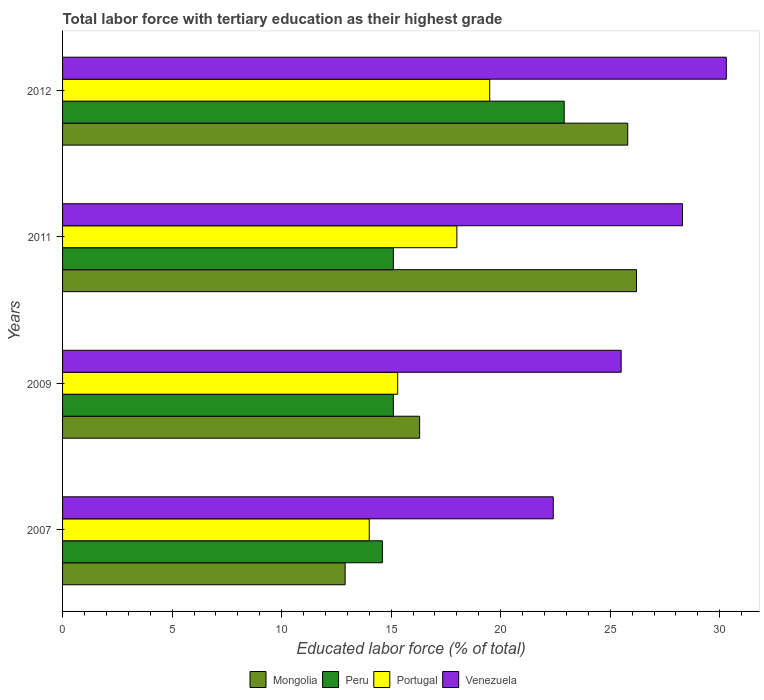How many different coloured bars are there?
Your answer should be compact. 4. Are the number of bars on each tick of the Y-axis equal?
Your answer should be compact. Yes. How many bars are there on the 4th tick from the top?
Offer a very short reply. 4. In how many cases, is the number of bars for a given year not equal to the number of legend labels?
Offer a terse response. 0. Across all years, what is the maximum percentage of male labor force with tertiary education in Mongolia?
Provide a short and direct response. 26.2. Across all years, what is the minimum percentage of male labor force with tertiary education in Mongolia?
Offer a terse response. 12.9. In which year was the percentage of male labor force with tertiary education in Venezuela maximum?
Provide a short and direct response. 2012. What is the total percentage of male labor force with tertiary education in Peru in the graph?
Your answer should be very brief. 67.7. What is the difference between the percentage of male labor force with tertiary education in Mongolia in 2011 and that in 2012?
Keep it short and to the point. 0.4. What is the difference between the percentage of male labor force with tertiary education in Mongolia in 2009 and the percentage of male labor force with tertiary education in Portugal in 2011?
Keep it short and to the point. -1.7. What is the average percentage of male labor force with tertiary education in Mongolia per year?
Your answer should be compact. 20.3. In the year 2012, what is the difference between the percentage of male labor force with tertiary education in Mongolia and percentage of male labor force with tertiary education in Peru?
Your response must be concise. 2.9. What is the ratio of the percentage of male labor force with tertiary education in Peru in 2011 to that in 2012?
Offer a terse response. 0.66. Is the percentage of male labor force with tertiary education in Peru in 2007 less than that in 2009?
Your answer should be very brief. Yes. Is the difference between the percentage of male labor force with tertiary education in Mongolia in 2007 and 2009 greater than the difference between the percentage of male labor force with tertiary education in Peru in 2007 and 2009?
Provide a succinct answer. No. What is the difference between the highest and the lowest percentage of male labor force with tertiary education in Venezuela?
Provide a succinct answer. 7.9. Is the sum of the percentage of male labor force with tertiary education in Peru in 2009 and 2012 greater than the maximum percentage of male labor force with tertiary education in Portugal across all years?
Give a very brief answer. Yes. Is it the case that in every year, the sum of the percentage of male labor force with tertiary education in Portugal and percentage of male labor force with tertiary education in Venezuela is greater than the sum of percentage of male labor force with tertiary education in Mongolia and percentage of male labor force with tertiary education in Peru?
Provide a short and direct response. Yes. What does the 4th bar from the top in 2012 represents?
Provide a succinct answer. Mongolia. Are all the bars in the graph horizontal?
Your answer should be very brief. Yes. What is the difference between two consecutive major ticks on the X-axis?
Keep it short and to the point. 5. Are the values on the major ticks of X-axis written in scientific E-notation?
Offer a terse response. No. Does the graph contain grids?
Your answer should be compact. No. How many legend labels are there?
Your response must be concise. 4. How are the legend labels stacked?
Offer a very short reply. Horizontal. What is the title of the graph?
Make the answer very short. Total labor force with tertiary education as their highest grade. Does "Azerbaijan" appear as one of the legend labels in the graph?
Provide a succinct answer. No. What is the label or title of the X-axis?
Offer a terse response. Educated labor force (% of total). What is the label or title of the Y-axis?
Your answer should be compact. Years. What is the Educated labor force (% of total) in Mongolia in 2007?
Offer a very short reply. 12.9. What is the Educated labor force (% of total) of Peru in 2007?
Your response must be concise. 14.6. What is the Educated labor force (% of total) in Portugal in 2007?
Your response must be concise. 14. What is the Educated labor force (% of total) of Venezuela in 2007?
Make the answer very short. 22.4. What is the Educated labor force (% of total) in Mongolia in 2009?
Keep it short and to the point. 16.3. What is the Educated labor force (% of total) of Peru in 2009?
Your answer should be very brief. 15.1. What is the Educated labor force (% of total) of Portugal in 2009?
Offer a very short reply. 15.3. What is the Educated labor force (% of total) of Mongolia in 2011?
Make the answer very short. 26.2. What is the Educated labor force (% of total) in Peru in 2011?
Your response must be concise. 15.1. What is the Educated labor force (% of total) in Venezuela in 2011?
Your response must be concise. 28.3. What is the Educated labor force (% of total) in Mongolia in 2012?
Make the answer very short. 25.8. What is the Educated labor force (% of total) in Peru in 2012?
Provide a succinct answer. 22.9. What is the Educated labor force (% of total) of Portugal in 2012?
Keep it short and to the point. 19.5. What is the Educated labor force (% of total) of Venezuela in 2012?
Make the answer very short. 30.3. Across all years, what is the maximum Educated labor force (% of total) of Mongolia?
Your answer should be very brief. 26.2. Across all years, what is the maximum Educated labor force (% of total) in Peru?
Provide a short and direct response. 22.9. Across all years, what is the maximum Educated labor force (% of total) of Venezuela?
Keep it short and to the point. 30.3. Across all years, what is the minimum Educated labor force (% of total) of Mongolia?
Provide a short and direct response. 12.9. Across all years, what is the minimum Educated labor force (% of total) in Peru?
Your answer should be very brief. 14.6. Across all years, what is the minimum Educated labor force (% of total) in Portugal?
Your response must be concise. 14. Across all years, what is the minimum Educated labor force (% of total) in Venezuela?
Offer a terse response. 22.4. What is the total Educated labor force (% of total) in Mongolia in the graph?
Offer a very short reply. 81.2. What is the total Educated labor force (% of total) of Peru in the graph?
Offer a terse response. 67.7. What is the total Educated labor force (% of total) in Portugal in the graph?
Give a very brief answer. 66.8. What is the total Educated labor force (% of total) of Venezuela in the graph?
Your response must be concise. 106.5. What is the difference between the Educated labor force (% of total) of Mongolia in 2007 and that in 2009?
Your response must be concise. -3.4. What is the difference between the Educated labor force (% of total) of Venezuela in 2007 and that in 2009?
Ensure brevity in your answer.  -3.1. What is the difference between the Educated labor force (% of total) in Peru in 2007 and that in 2011?
Offer a terse response. -0.5. What is the difference between the Educated labor force (% of total) in Mongolia in 2007 and that in 2012?
Ensure brevity in your answer.  -12.9. What is the difference between the Educated labor force (% of total) in Peru in 2007 and that in 2012?
Give a very brief answer. -8.3. What is the difference between the Educated labor force (% of total) in Venezuela in 2007 and that in 2012?
Provide a short and direct response. -7.9. What is the difference between the Educated labor force (% of total) of Peru in 2009 and that in 2012?
Offer a very short reply. -7.8. What is the difference between the Educated labor force (% of total) of Venezuela in 2009 and that in 2012?
Your answer should be compact. -4.8. What is the difference between the Educated labor force (% of total) in Portugal in 2011 and that in 2012?
Offer a terse response. -1.5. What is the difference between the Educated labor force (% of total) in Mongolia in 2007 and the Educated labor force (% of total) in Peru in 2009?
Give a very brief answer. -2.2. What is the difference between the Educated labor force (% of total) in Mongolia in 2007 and the Educated labor force (% of total) in Venezuela in 2009?
Keep it short and to the point. -12.6. What is the difference between the Educated labor force (% of total) in Peru in 2007 and the Educated labor force (% of total) in Portugal in 2009?
Make the answer very short. -0.7. What is the difference between the Educated labor force (% of total) of Peru in 2007 and the Educated labor force (% of total) of Venezuela in 2009?
Provide a succinct answer. -10.9. What is the difference between the Educated labor force (% of total) of Mongolia in 2007 and the Educated labor force (% of total) of Peru in 2011?
Make the answer very short. -2.2. What is the difference between the Educated labor force (% of total) in Mongolia in 2007 and the Educated labor force (% of total) in Portugal in 2011?
Provide a short and direct response. -5.1. What is the difference between the Educated labor force (% of total) of Mongolia in 2007 and the Educated labor force (% of total) of Venezuela in 2011?
Your answer should be compact. -15.4. What is the difference between the Educated labor force (% of total) of Peru in 2007 and the Educated labor force (% of total) of Portugal in 2011?
Your response must be concise. -3.4. What is the difference between the Educated labor force (% of total) in Peru in 2007 and the Educated labor force (% of total) in Venezuela in 2011?
Make the answer very short. -13.7. What is the difference between the Educated labor force (% of total) of Portugal in 2007 and the Educated labor force (% of total) of Venezuela in 2011?
Offer a very short reply. -14.3. What is the difference between the Educated labor force (% of total) of Mongolia in 2007 and the Educated labor force (% of total) of Venezuela in 2012?
Your answer should be very brief. -17.4. What is the difference between the Educated labor force (% of total) of Peru in 2007 and the Educated labor force (% of total) of Venezuela in 2012?
Offer a very short reply. -15.7. What is the difference between the Educated labor force (% of total) in Portugal in 2007 and the Educated labor force (% of total) in Venezuela in 2012?
Keep it short and to the point. -16.3. What is the difference between the Educated labor force (% of total) in Mongolia in 2009 and the Educated labor force (% of total) in Peru in 2011?
Your answer should be compact. 1.2. What is the difference between the Educated labor force (% of total) in Mongolia in 2009 and the Educated labor force (% of total) in Venezuela in 2011?
Give a very brief answer. -12. What is the difference between the Educated labor force (% of total) in Portugal in 2009 and the Educated labor force (% of total) in Venezuela in 2011?
Your response must be concise. -13. What is the difference between the Educated labor force (% of total) in Mongolia in 2009 and the Educated labor force (% of total) in Portugal in 2012?
Offer a very short reply. -3.2. What is the difference between the Educated labor force (% of total) in Mongolia in 2009 and the Educated labor force (% of total) in Venezuela in 2012?
Offer a terse response. -14. What is the difference between the Educated labor force (% of total) of Peru in 2009 and the Educated labor force (% of total) of Portugal in 2012?
Your answer should be compact. -4.4. What is the difference between the Educated labor force (% of total) of Peru in 2009 and the Educated labor force (% of total) of Venezuela in 2012?
Give a very brief answer. -15.2. What is the difference between the Educated labor force (% of total) of Portugal in 2009 and the Educated labor force (% of total) of Venezuela in 2012?
Your answer should be compact. -15. What is the difference between the Educated labor force (% of total) in Mongolia in 2011 and the Educated labor force (% of total) in Peru in 2012?
Offer a terse response. 3.3. What is the difference between the Educated labor force (% of total) in Mongolia in 2011 and the Educated labor force (% of total) in Venezuela in 2012?
Offer a very short reply. -4.1. What is the difference between the Educated labor force (% of total) in Peru in 2011 and the Educated labor force (% of total) in Portugal in 2012?
Your response must be concise. -4.4. What is the difference between the Educated labor force (% of total) in Peru in 2011 and the Educated labor force (% of total) in Venezuela in 2012?
Ensure brevity in your answer.  -15.2. What is the average Educated labor force (% of total) in Mongolia per year?
Offer a terse response. 20.3. What is the average Educated labor force (% of total) in Peru per year?
Make the answer very short. 16.93. What is the average Educated labor force (% of total) of Venezuela per year?
Offer a terse response. 26.62. In the year 2007, what is the difference between the Educated labor force (% of total) of Mongolia and Educated labor force (% of total) of Peru?
Your response must be concise. -1.7. In the year 2007, what is the difference between the Educated labor force (% of total) in Peru and Educated labor force (% of total) in Venezuela?
Your response must be concise. -7.8. In the year 2009, what is the difference between the Educated labor force (% of total) in Mongolia and Educated labor force (% of total) in Portugal?
Provide a succinct answer. 1. In the year 2009, what is the difference between the Educated labor force (% of total) in Peru and Educated labor force (% of total) in Portugal?
Offer a terse response. -0.2. In the year 2009, what is the difference between the Educated labor force (% of total) of Peru and Educated labor force (% of total) of Venezuela?
Provide a succinct answer. -10.4. In the year 2011, what is the difference between the Educated labor force (% of total) of Mongolia and Educated labor force (% of total) of Peru?
Keep it short and to the point. 11.1. In the year 2011, what is the difference between the Educated labor force (% of total) of Peru and Educated labor force (% of total) of Venezuela?
Offer a very short reply. -13.2. In the year 2012, what is the difference between the Educated labor force (% of total) in Mongolia and Educated labor force (% of total) in Portugal?
Your response must be concise. 6.3. In the year 2012, what is the difference between the Educated labor force (% of total) of Peru and Educated labor force (% of total) of Portugal?
Make the answer very short. 3.4. In the year 2012, what is the difference between the Educated labor force (% of total) of Peru and Educated labor force (% of total) of Venezuela?
Give a very brief answer. -7.4. In the year 2012, what is the difference between the Educated labor force (% of total) of Portugal and Educated labor force (% of total) of Venezuela?
Provide a succinct answer. -10.8. What is the ratio of the Educated labor force (% of total) of Mongolia in 2007 to that in 2009?
Make the answer very short. 0.79. What is the ratio of the Educated labor force (% of total) in Peru in 2007 to that in 2009?
Ensure brevity in your answer.  0.97. What is the ratio of the Educated labor force (% of total) of Portugal in 2007 to that in 2009?
Make the answer very short. 0.92. What is the ratio of the Educated labor force (% of total) of Venezuela in 2007 to that in 2009?
Your response must be concise. 0.88. What is the ratio of the Educated labor force (% of total) in Mongolia in 2007 to that in 2011?
Ensure brevity in your answer.  0.49. What is the ratio of the Educated labor force (% of total) of Peru in 2007 to that in 2011?
Your answer should be very brief. 0.97. What is the ratio of the Educated labor force (% of total) of Venezuela in 2007 to that in 2011?
Provide a succinct answer. 0.79. What is the ratio of the Educated labor force (% of total) of Peru in 2007 to that in 2012?
Offer a very short reply. 0.64. What is the ratio of the Educated labor force (% of total) of Portugal in 2007 to that in 2012?
Your response must be concise. 0.72. What is the ratio of the Educated labor force (% of total) in Venezuela in 2007 to that in 2012?
Keep it short and to the point. 0.74. What is the ratio of the Educated labor force (% of total) in Mongolia in 2009 to that in 2011?
Your answer should be compact. 0.62. What is the ratio of the Educated labor force (% of total) of Peru in 2009 to that in 2011?
Give a very brief answer. 1. What is the ratio of the Educated labor force (% of total) in Venezuela in 2009 to that in 2011?
Offer a terse response. 0.9. What is the ratio of the Educated labor force (% of total) in Mongolia in 2009 to that in 2012?
Offer a very short reply. 0.63. What is the ratio of the Educated labor force (% of total) in Peru in 2009 to that in 2012?
Your answer should be very brief. 0.66. What is the ratio of the Educated labor force (% of total) in Portugal in 2009 to that in 2012?
Make the answer very short. 0.78. What is the ratio of the Educated labor force (% of total) in Venezuela in 2009 to that in 2012?
Provide a succinct answer. 0.84. What is the ratio of the Educated labor force (% of total) in Mongolia in 2011 to that in 2012?
Provide a succinct answer. 1.02. What is the ratio of the Educated labor force (% of total) in Peru in 2011 to that in 2012?
Provide a short and direct response. 0.66. What is the ratio of the Educated labor force (% of total) in Venezuela in 2011 to that in 2012?
Keep it short and to the point. 0.93. What is the difference between the highest and the second highest Educated labor force (% of total) in Peru?
Offer a very short reply. 7.8. What is the difference between the highest and the second highest Educated labor force (% of total) of Venezuela?
Provide a short and direct response. 2. What is the difference between the highest and the lowest Educated labor force (% of total) in Mongolia?
Offer a terse response. 13.3. What is the difference between the highest and the lowest Educated labor force (% of total) of Venezuela?
Ensure brevity in your answer.  7.9. 